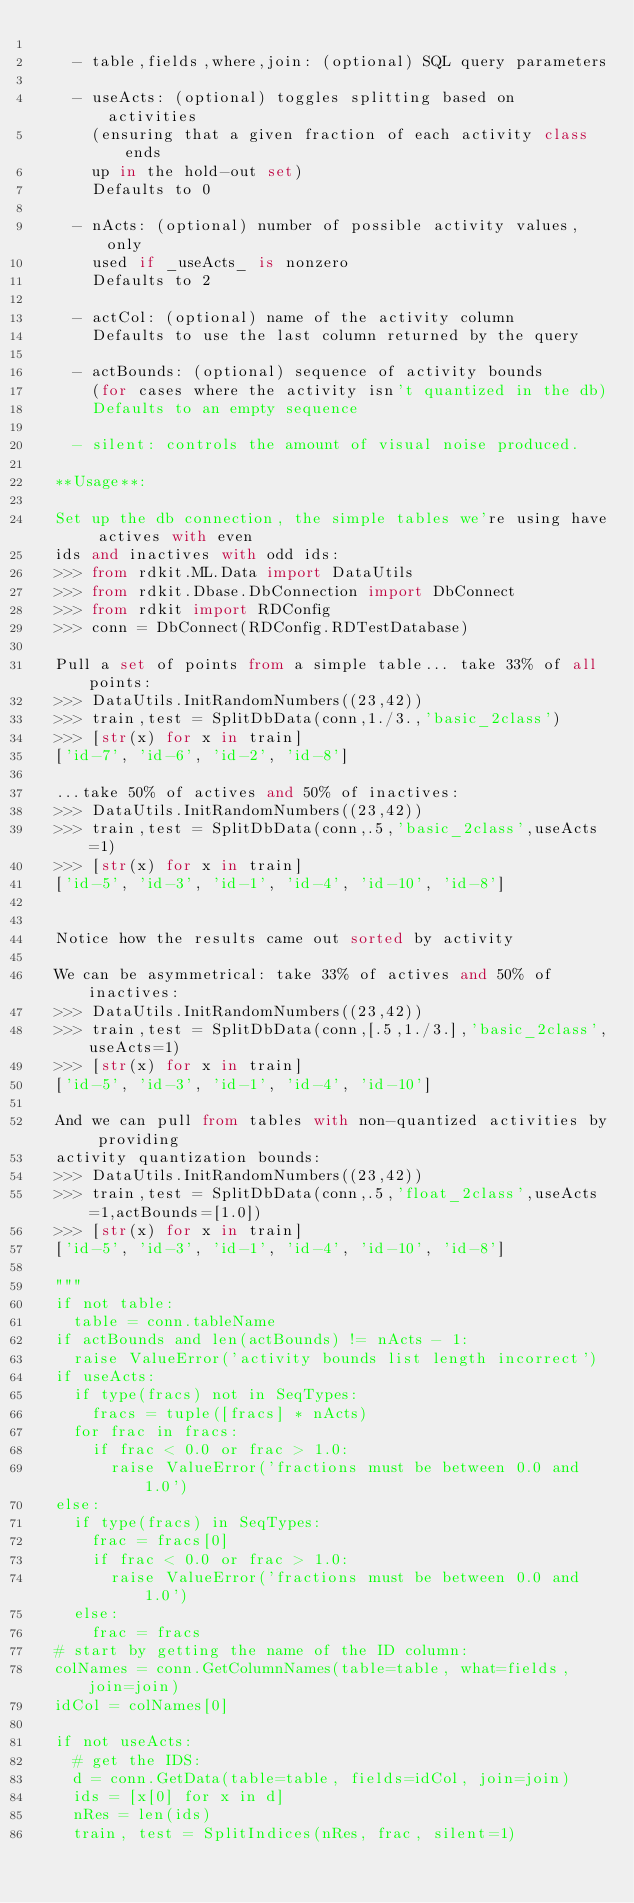<code> <loc_0><loc_0><loc_500><loc_500><_Python_>
    - table,fields,where,join: (optional) SQL query parameters

    - useActs: (optional) toggles splitting based on activities
      (ensuring that a given fraction of each activity class ends
      up in the hold-out set)
      Defaults to 0

    - nActs: (optional) number of possible activity values, only
      used if _useActs_ is nonzero
      Defaults to 2

    - actCol: (optional) name of the activity column
      Defaults to use the last column returned by the query

    - actBounds: (optional) sequence of activity bounds
      (for cases where the activity isn't quantized in the db)
      Defaults to an empty sequence

    - silent: controls the amount of visual noise produced.

  **Usage**:

  Set up the db connection, the simple tables we're using have actives with even
  ids and inactives with odd ids:
  >>> from rdkit.ML.Data import DataUtils
  >>> from rdkit.Dbase.DbConnection import DbConnect
  >>> from rdkit import RDConfig
  >>> conn = DbConnect(RDConfig.RDTestDatabase)

  Pull a set of points from a simple table... take 33% of all points:
  >>> DataUtils.InitRandomNumbers((23,42))
  >>> train,test = SplitDbData(conn,1./3.,'basic_2class')
  >>> [str(x) for x in train]
  ['id-7', 'id-6', 'id-2', 'id-8']

  ...take 50% of actives and 50% of inactives:
  >>> DataUtils.InitRandomNumbers((23,42))
  >>> train,test = SplitDbData(conn,.5,'basic_2class',useActs=1)
  >>> [str(x) for x in train]
  ['id-5', 'id-3', 'id-1', 'id-4', 'id-10', 'id-8']


  Notice how the results came out sorted by activity

  We can be asymmetrical: take 33% of actives and 50% of inactives:
  >>> DataUtils.InitRandomNumbers((23,42))
  >>> train,test = SplitDbData(conn,[.5,1./3.],'basic_2class',useActs=1)
  >>> [str(x) for x in train]
  ['id-5', 'id-3', 'id-1', 'id-4', 'id-10']

  And we can pull from tables with non-quantized activities by providing
  activity quantization bounds:
  >>> DataUtils.InitRandomNumbers((23,42))
  >>> train,test = SplitDbData(conn,.5,'float_2class',useActs=1,actBounds=[1.0])
  >>> [str(x) for x in train]
  ['id-5', 'id-3', 'id-1', 'id-4', 'id-10', 'id-8']

  """
  if not table:
    table = conn.tableName
  if actBounds and len(actBounds) != nActs - 1:
    raise ValueError('activity bounds list length incorrect')
  if useActs:
    if type(fracs) not in SeqTypes:
      fracs = tuple([fracs] * nActs)
    for frac in fracs:
      if frac < 0.0 or frac > 1.0:
        raise ValueError('fractions must be between 0.0 and 1.0')
  else:
    if type(fracs) in SeqTypes:
      frac = fracs[0]
      if frac < 0.0 or frac > 1.0:
        raise ValueError('fractions must be between 0.0 and 1.0')
    else:
      frac = fracs
  # start by getting the name of the ID column:
  colNames = conn.GetColumnNames(table=table, what=fields, join=join)
  idCol = colNames[0]

  if not useActs:
    # get the IDS:
    d = conn.GetData(table=table, fields=idCol, join=join)
    ids = [x[0] for x in d]
    nRes = len(ids)
    train, test = SplitIndices(nRes, frac, silent=1)</code> 